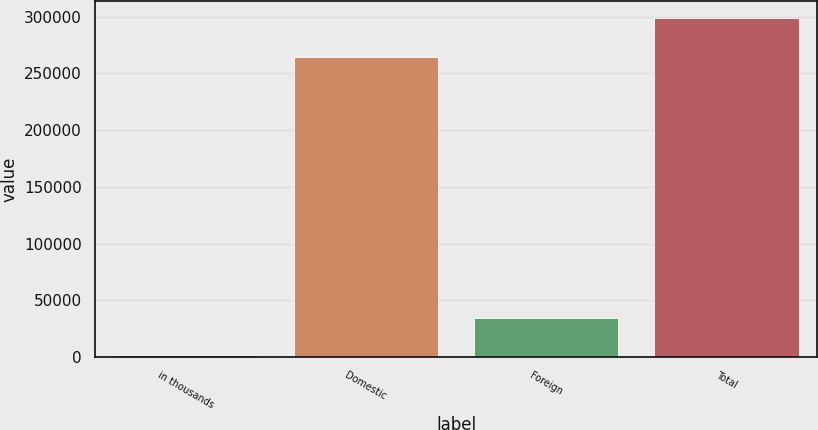Convert chart. <chart><loc_0><loc_0><loc_500><loc_500><bar_chart><fcel>in thousands<fcel>Domestic<fcel>Foreign<fcel>Total<nl><fcel>2014<fcel>264473<fcel>34365<fcel>298838<nl></chart> 